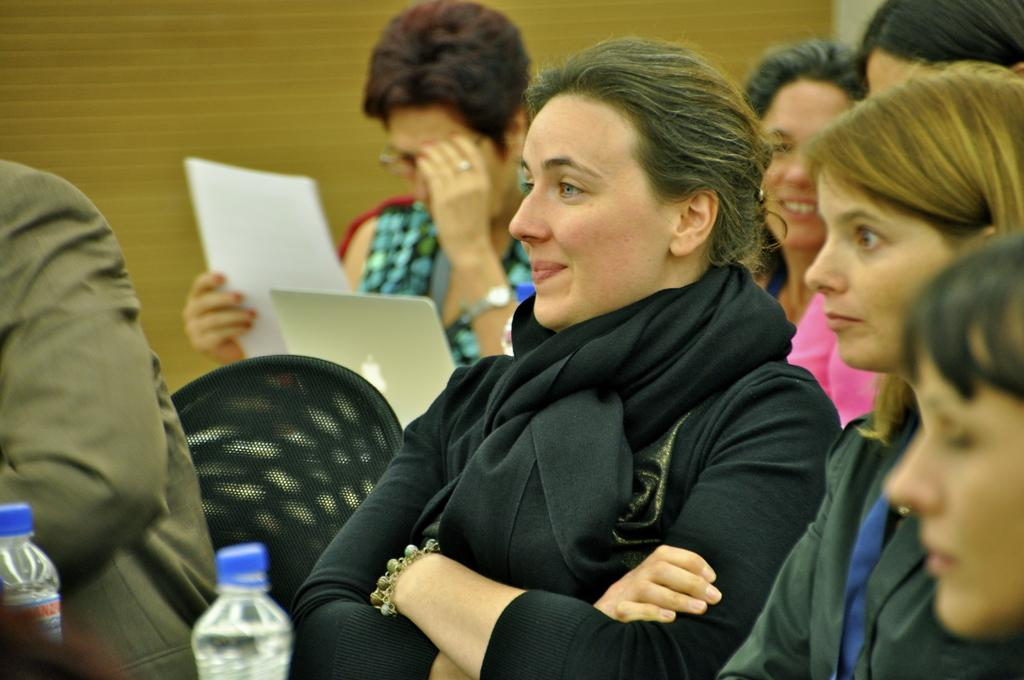What are the people in the image doing? The people in the image are seated on chairs. What items can be seen on the table in the image? Water bottles are visible in the image. What is the woman holding in the image? A woman is holding a paper in the image. What electronic device is present in the image? A laptop is present in the image. What type of iron can be seen in the image? There is no iron present in the image. Where is the park located in the image? There is no park present in the image. 